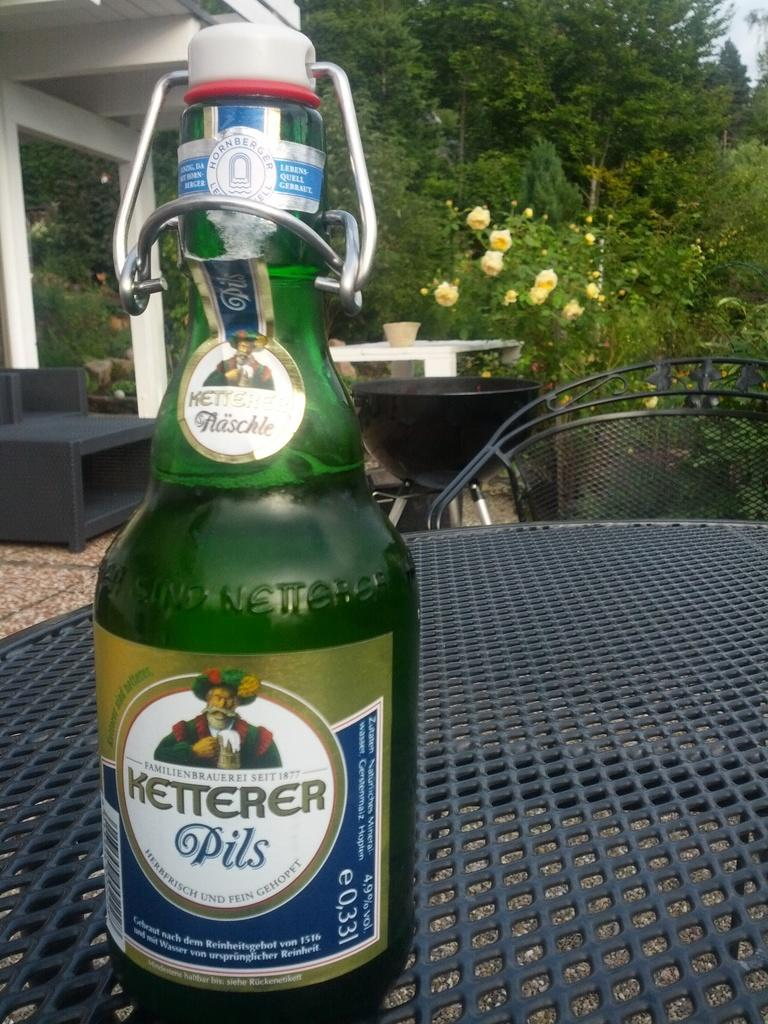<image>
Write a terse but informative summary of the picture. The beer shown has 4.9% alcohol volume in the bottle. 